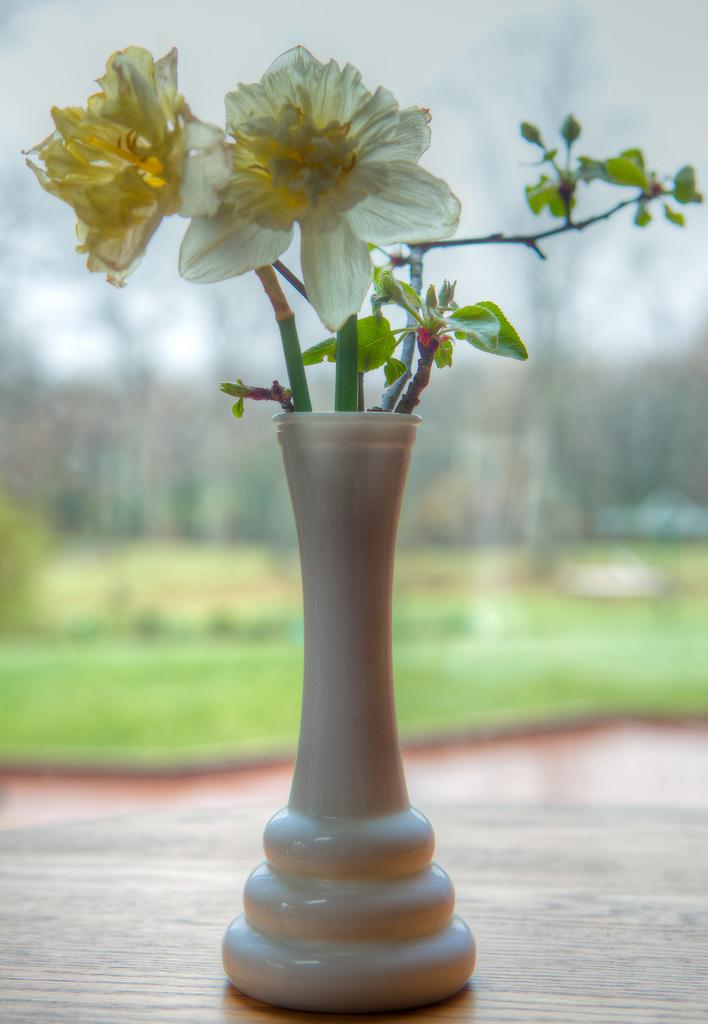What object is located on the table in the foreground of the image? There is a flower vase on a table in the foreground. What can be seen in the background of the image? There are trees and plants in the background. How is the background of the image depicted? The background is blurry. How many fingers can be seen touching the pet in the image? There is no pet present in the image, and therefore no fingers can be seen touching it. 